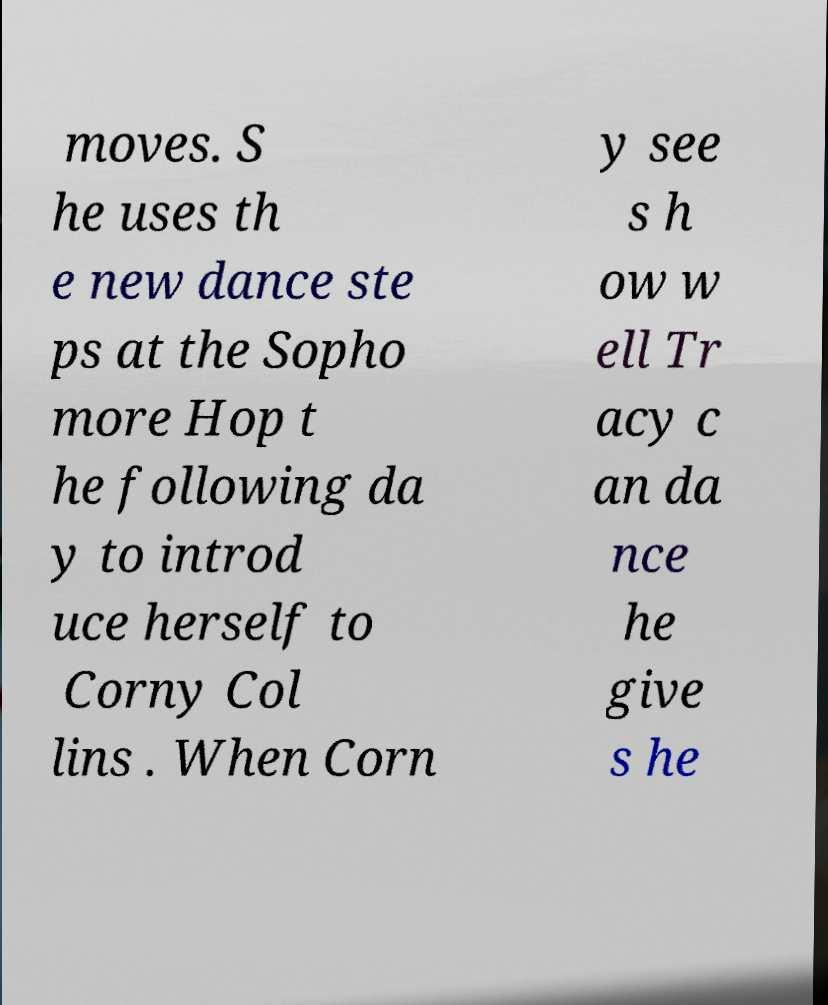There's text embedded in this image that I need extracted. Can you transcribe it verbatim? moves. S he uses th e new dance ste ps at the Sopho more Hop t he following da y to introd uce herself to Corny Col lins . When Corn y see s h ow w ell Tr acy c an da nce he give s he 